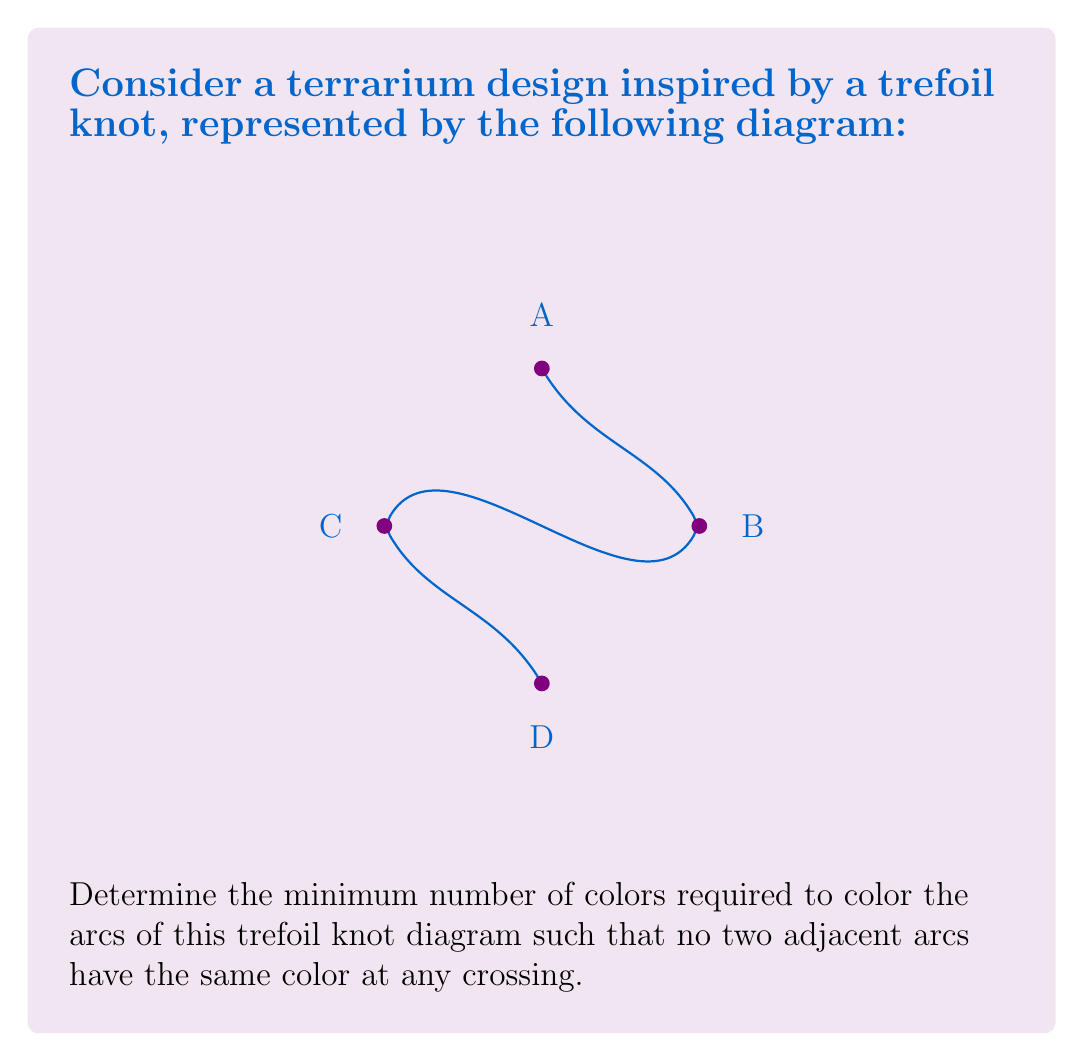Provide a solution to this math problem. To solve this problem, we'll use the concept of colorability in knot theory:

1) First, recall that the minimum number of colors required to color a knot diagram is always either 1, 2, or 3.

2) A knot diagram is 1-colorable if and only if it represents the unknot (which is not the case here).

3) To determine if the knot is 2-colorable or 3-colorable, we can use the following method:
   - Assign colors alternately as we travel along the knot.
   - If we return to the starting point with the same color, the knot is 2-colorable.
   - If we return with a different color, the knot is 3-colorable.

4) Let's start coloring from point A:
   - Arc AB: Color 1
   - Arc BC: Color 2
   - Arc CD: Color 1
   - Arc DA: Color 2

5) We've returned to point A with Color 2, which is different from the starting color (Color 1).

6) This means the trefoil knot diagram is not 2-colorable.

7) Therefore, the minimum number of colors required is 3.

We can verify this by assigning three colors:
   - Arc AB: Color 1
   - Arc BC: Color 2
   - Arc CD: Color 3
   - Arc DA: Color 1

This coloring satisfies the condition that no two adjacent arcs have the same color at any crossing.
Answer: 3 colors 